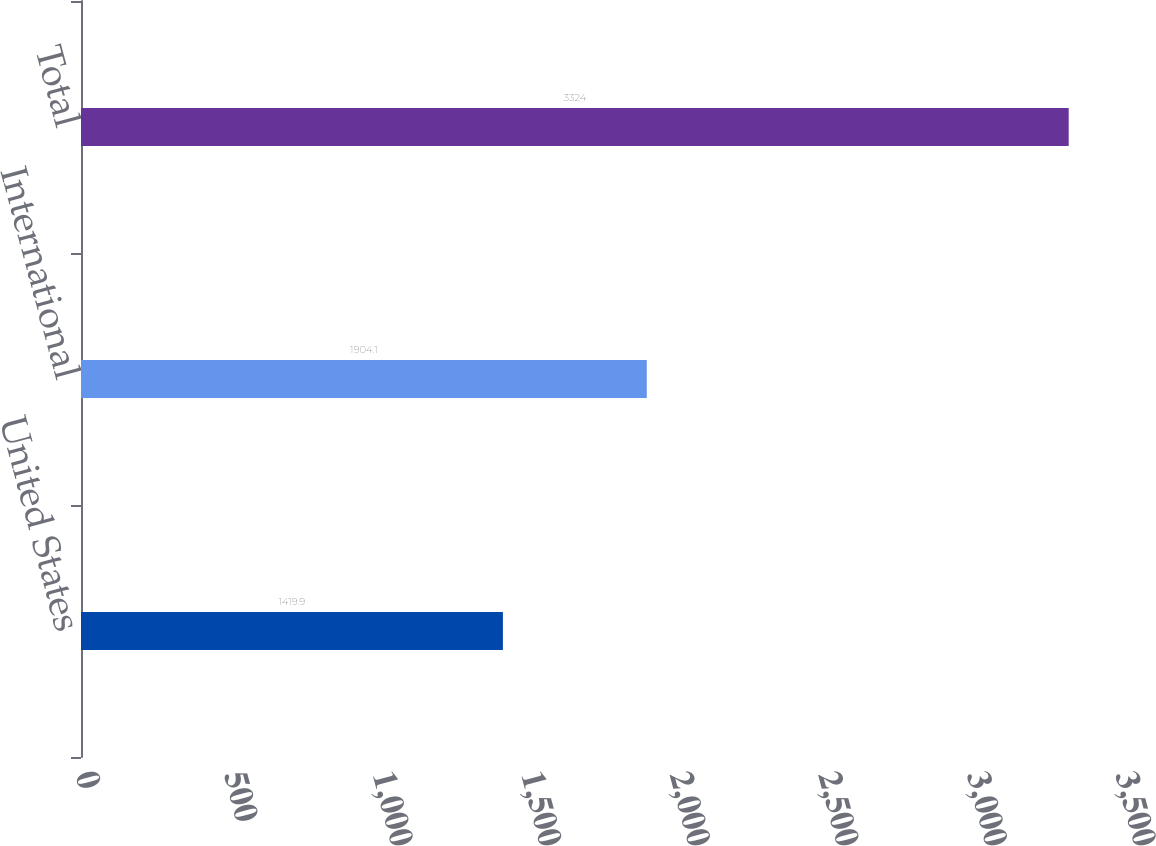Convert chart. <chart><loc_0><loc_0><loc_500><loc_500><bar_chart><fcel>United States<fcel>International<fcel>Total<nl><fcel>1419.9<fcel>1904.1<fcel>3324<nl></chart> 